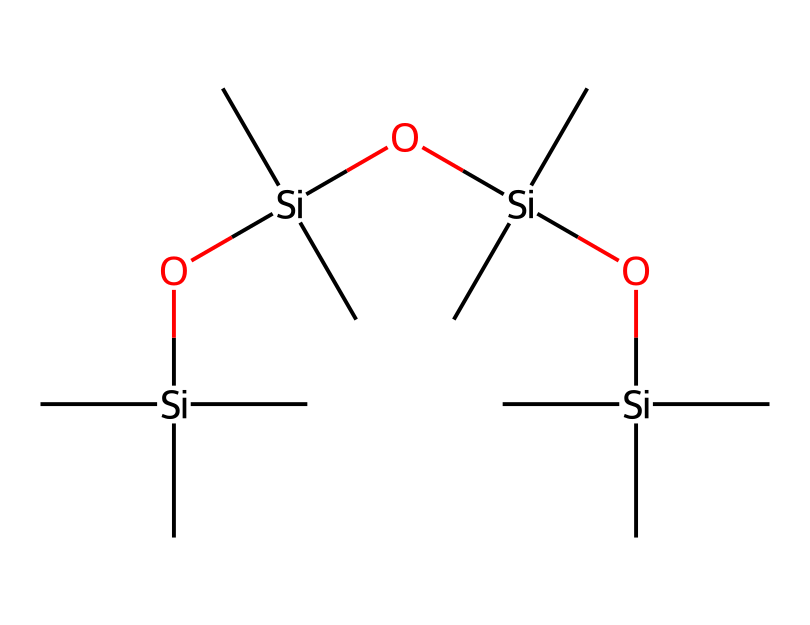What is the total number of silicon atoms in this chemical structure? The chemical structure provided includes three siloxane units (each linked by oxygen) and a terminal silicon atom. Counting the silicon atoms, there are four total: one at the end and three within the repeating units.
Answer: four How many oxygen atoms are present in the structure? Each siloxane unit contains one oxygen atom. Since there are three siloxane units linked together, there are three oxygen atoms in total.
Answer: three What type of chemical bonds are primarily present in this structure? The chemical structure illustrates siloxane linkages, which are characterized by silicon-oxygen bonds. In addition, there are carbon-silicon and carbon-carbon bonds present in the side groups. However, the primary bonds are silicon-oxygen.
Answer: silicon-oxygen What does the presence of methyl groups indicate about the properties of this compound? The presence of methyl groups in this structure suggests the chemical is organosilicon. Methyl groups contribute to the hydrophobic character and can enhance compatibility with other organic substances, which is desirable in cosmetics.
Answer: organosilicon How does the repeating structure of siloxanes affect their function in personal care products? The repeating structure allows for flexibility and a smooth texture, which is essential for the emollient properties in personal care products. It also helps form films that can provide a conditioning effect on hair and skin.
Answer: flexibility What is the significance of the branched structure in this compound? The branched structure of this siloxane affects its efficacy and behavior in formulations. It contributes to the compound's lower surface tension, which can improve spreadability on skin and hair, enhancing product application.
Answer: lower surface tension 